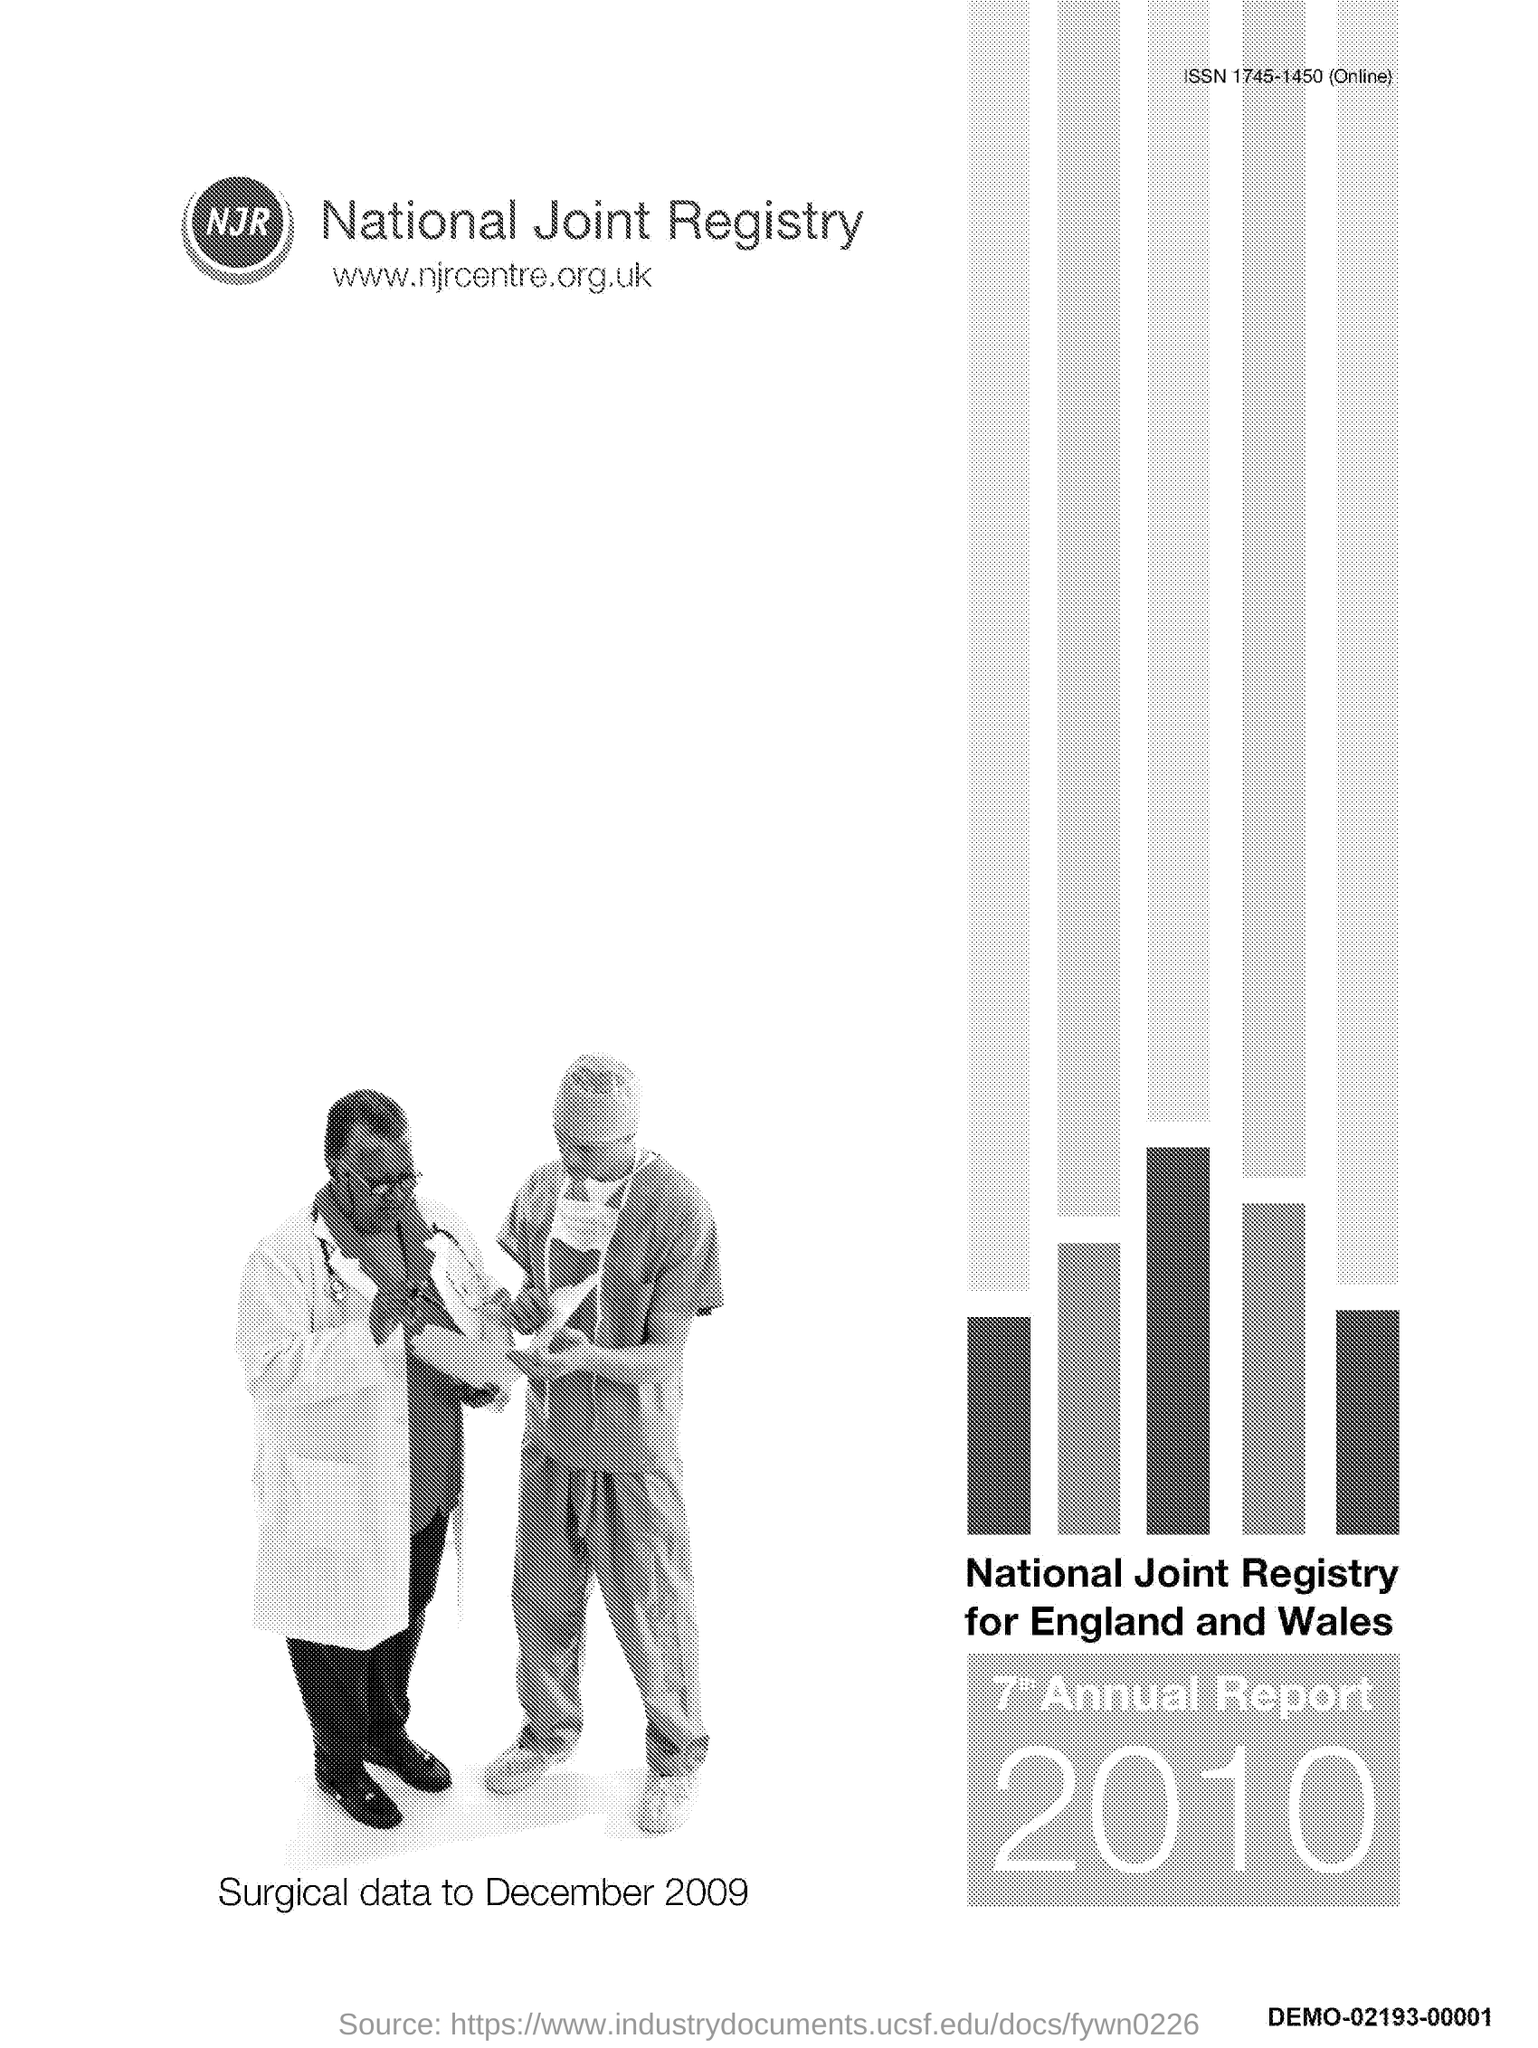What is the ISSN code?
Provide a short and direct response. 1745-1450. What is the website address?
Offer a very short reply. Www.njrcentre.org.uk. Which year's report is it?
Provide a short and direct response. 2010. 